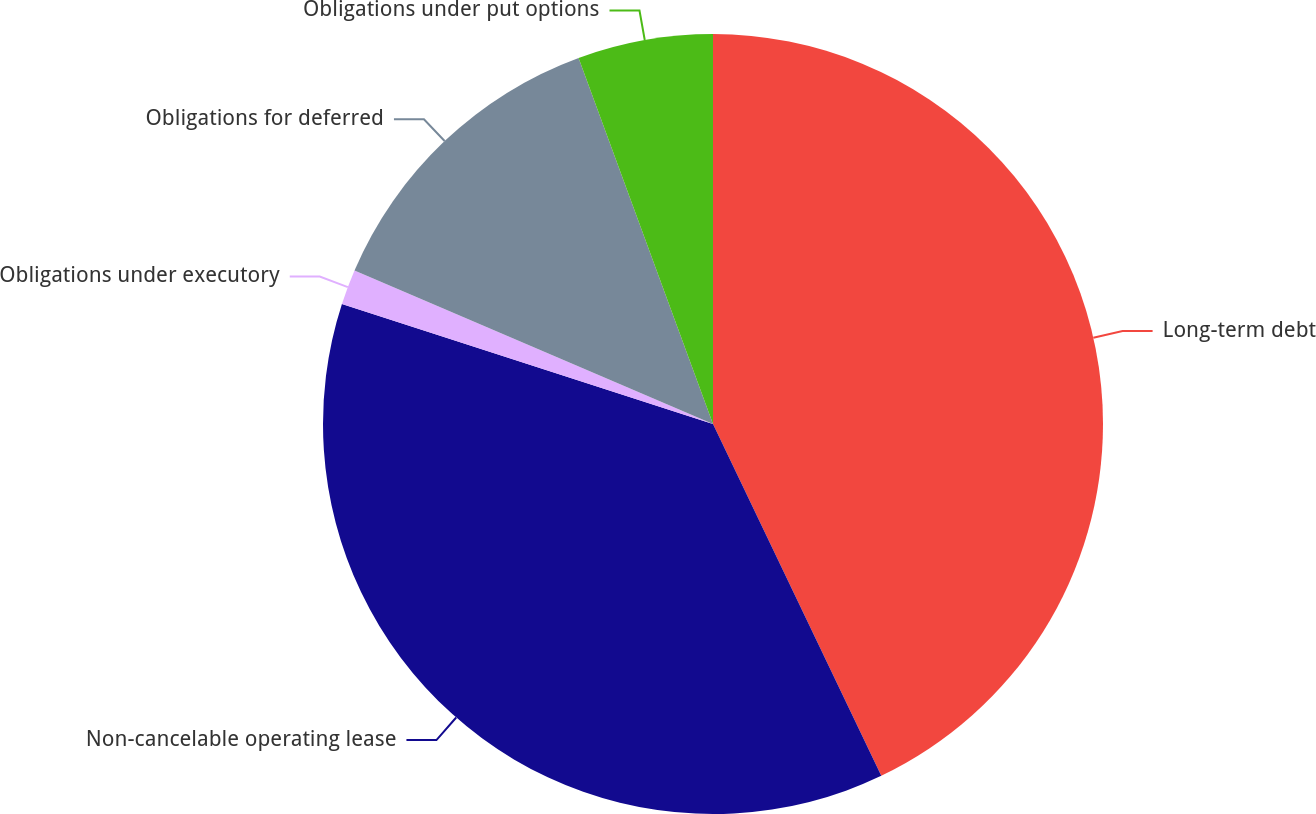Convert chart to OTSL. <chart><loc_0><loc_0><loc_500><loc_500><pie_chart><fcel>Long-term debt<fcel>Non-cancelable operating lease<fcel>Obligations under executory<fcel>Obligations for deferred<fcel>Obligations under put options<nl><fcel>42.9%<fcel>37.08%<fcel>1.46%<fcel>12.96%<fcel>5.6%<nl></chart> 